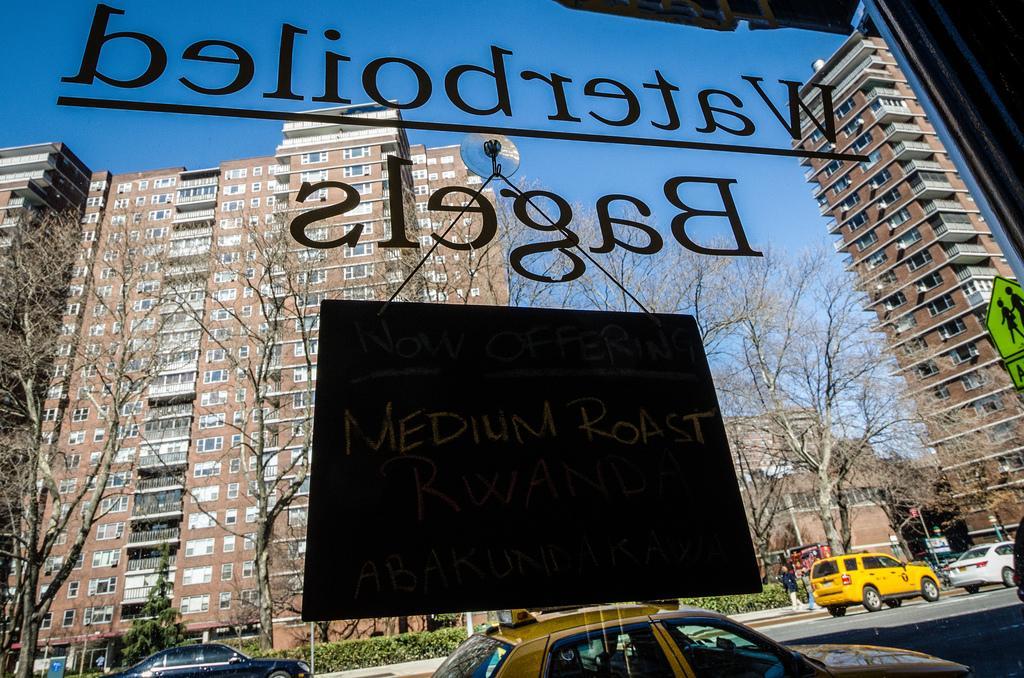Describe this image in one or two sentences. In the picture we can see a view from a restaurant window with a glass and from it we can see outside with road and some vehicles on it behind it, we can see a path with some poles and plants and behind it, we can see some trees and buildings with windows and glasses in it and in the background we can see a sky. 